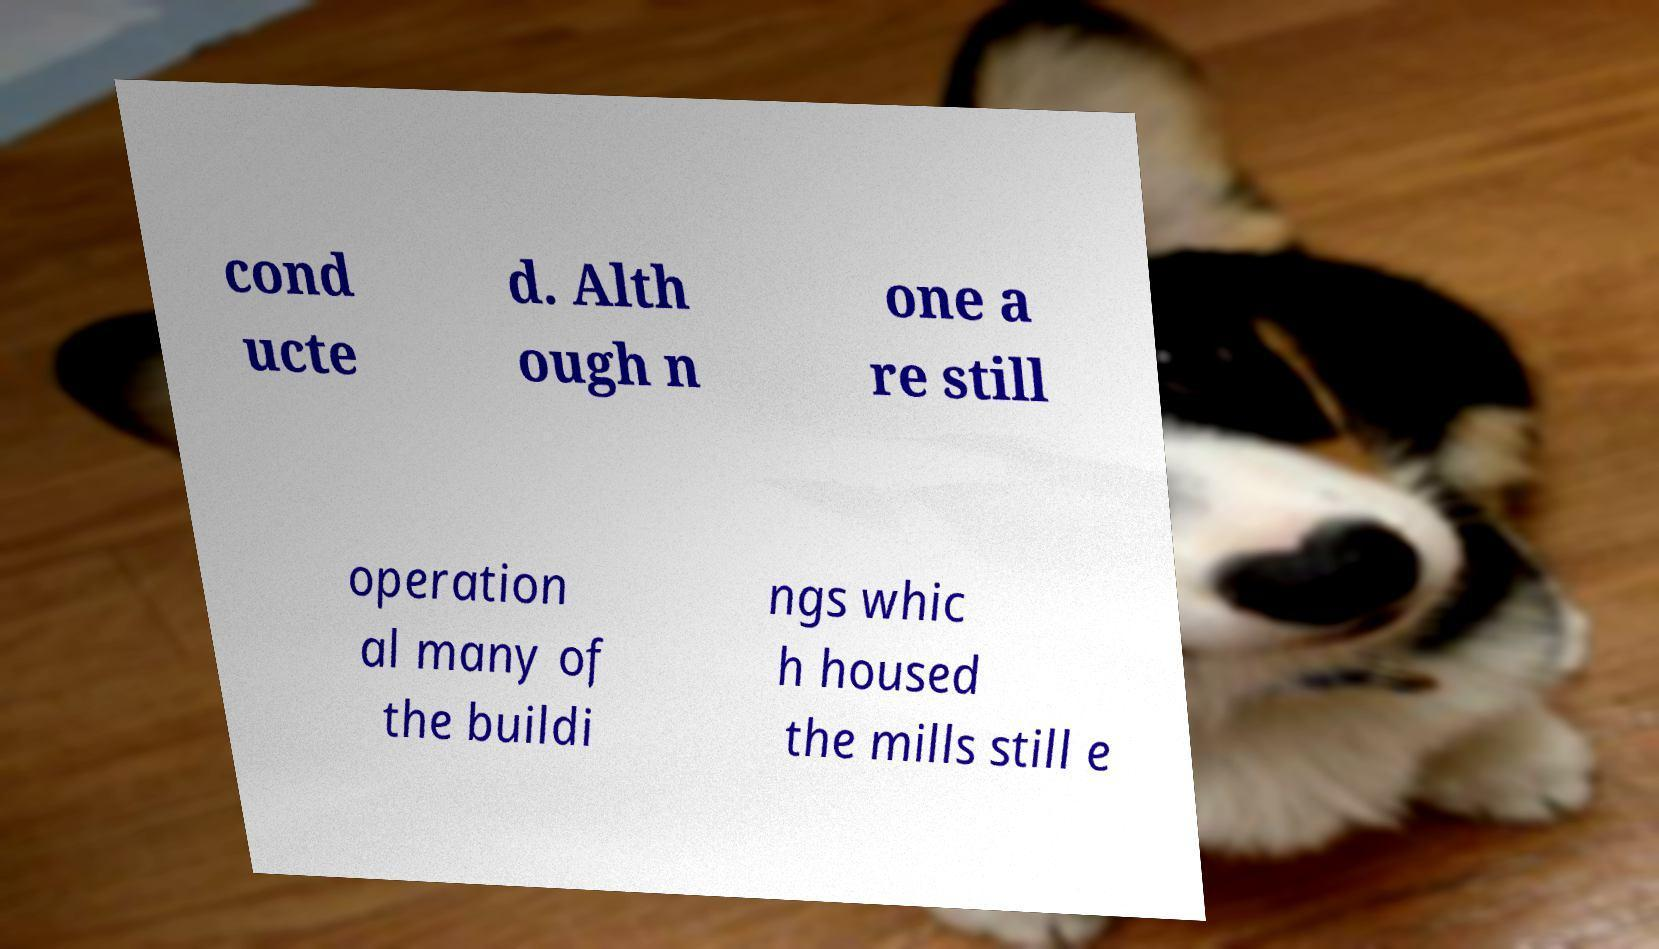Can you read and provide the text displayed in the image?This photo seems to have some interesting text. Can you extract and type it out for me? cond ucte d. Alth ough n one a re still operation al many of the buildi ngs whic h housed the mills still e 